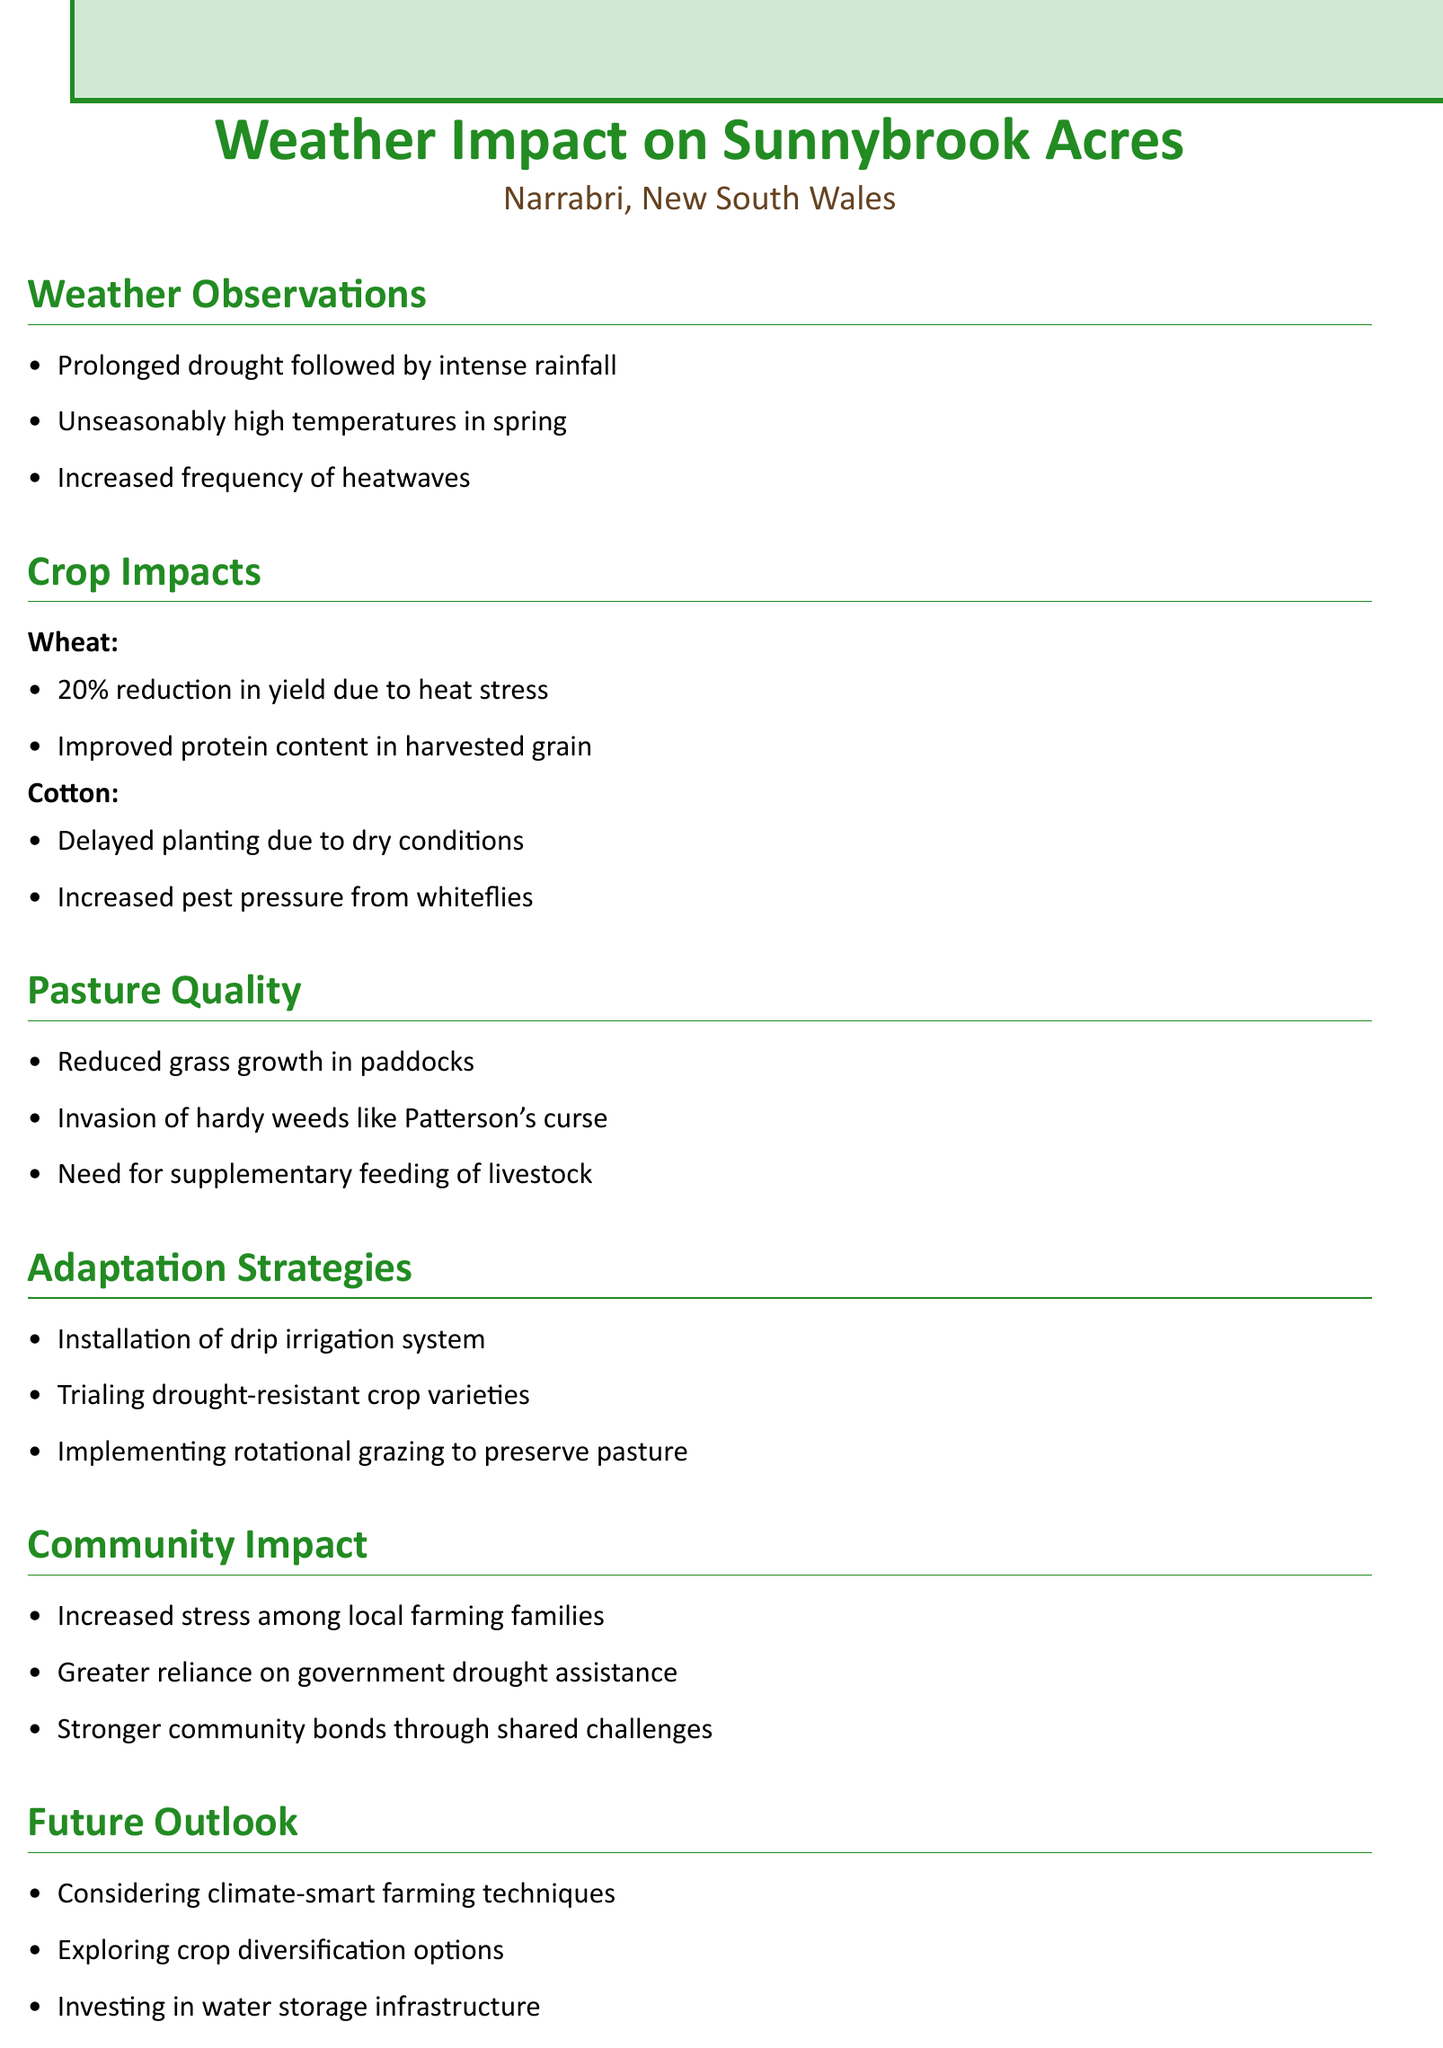What is the name of the farm? The name of the farm is mentioned in the document as "Sunnybrook Acres."
Answer: Sunnybrook Acres Where is the farm located? The document specifies the location of the farm as "Narrabri, New South Wales."
Answer: Narrabri, New South Wales What crop had a 20% reduction in yield? The document indicates that wheat suffered a 20% reduction in yield due to heat stress.
Answer: Wheat What is one adaptation strategy mentioned? The document lists several adaptation strategies, one of which is the "Installation of drip irrigation system."
Answer: Installation of drip irrigation system What has been a community impact noted? The document points out that there has been an "Increased stress among local farming families" as a community impact.
Answer: Increased stress among local farming families What type of weather pattern was observed? The observations include "Prolonged drought followed by intense rainfall" as a notable weather pattern.
Answer: Prolonged drought followed by intense rainfall What pest increased pressure on cotton crops? According to the document, "whiteflies" increased pest pressure on cotton crops.
Answer: Whiteflies What future strategy is being considered? The document suggests that the farmer is "Considering climate-smart farming techniques" as part of future planning.
Answer: Considering climate-smart farming techniques 